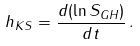Convert formula to latex. <formula><loc_0><loc_0><loc_500><loc_500>h _ { K S } = \frac { d ( \ln S _ { G H } ) } { d t } \, .</formula> 